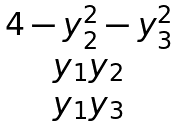Convert formula to latex. <formula><loc_0><loc_0><loc_500><loc_500>\begin{matrix} 4 - y _ { 2 } ^ { 2 } - y _ { 3 } ^ { 2 } \\ y _ { 1 } y _ { 2 } \\ y _ { 1 } y _ { 3 } \end{matrix}</formula> 